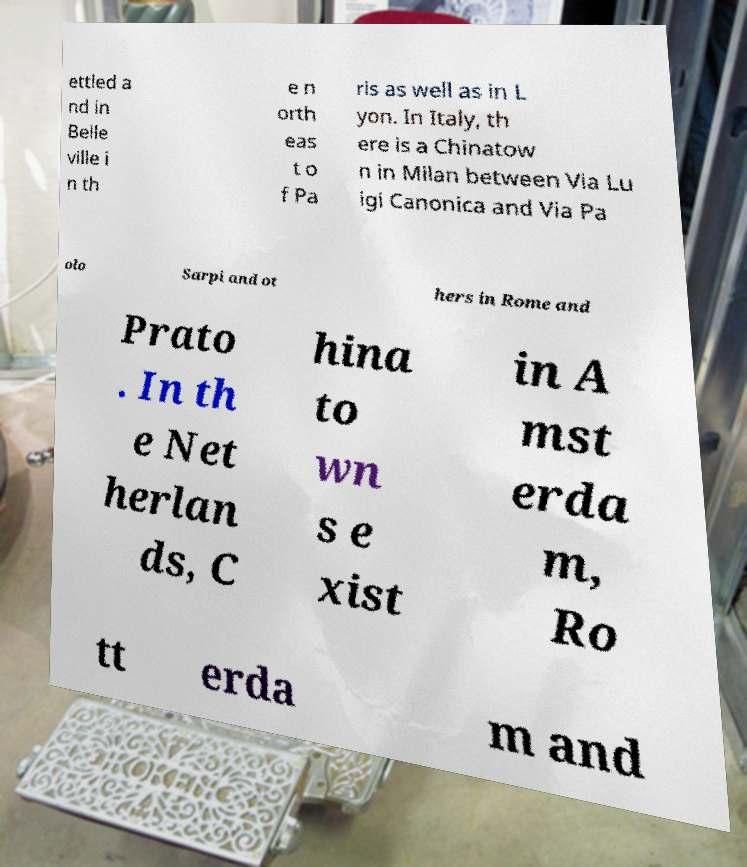Can you read and provide the text displayed in the image?This photo seems to have some interesting text. Can you extract and type it out for me? ettled a nd in Belle ville i n th e n orth eas t o f Pa ris as well as in L yon. In Italy, th ere is a Chinatow n in Milan between Via Lu igi Canonica and Via Pa olo Sarpi and ot hers in Rome and Prato . In th e Net herlan ds, C hina to wn s e xist in A mst erda m, Ro tt erda m and 